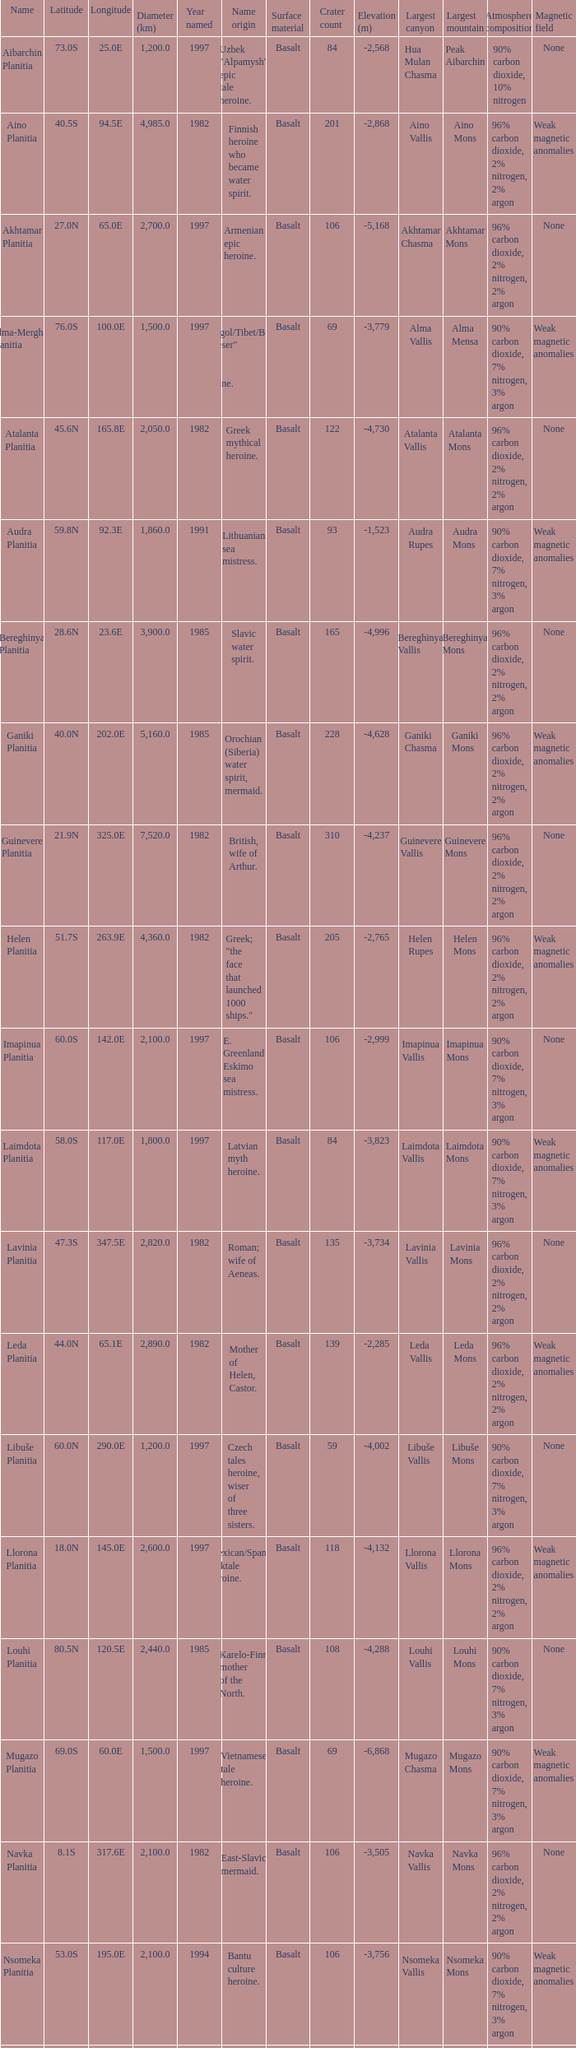0 km? Karelo-Finn mermaid. 